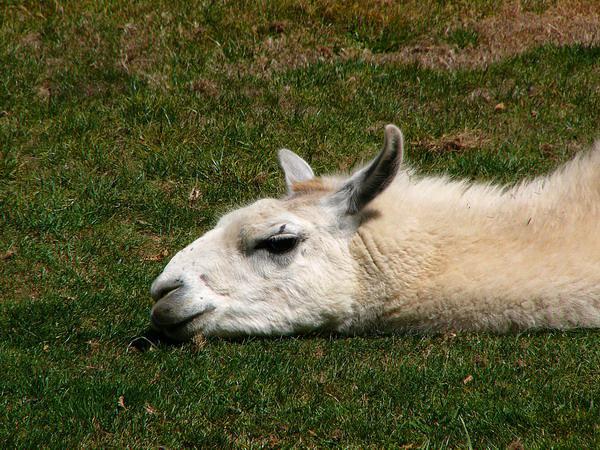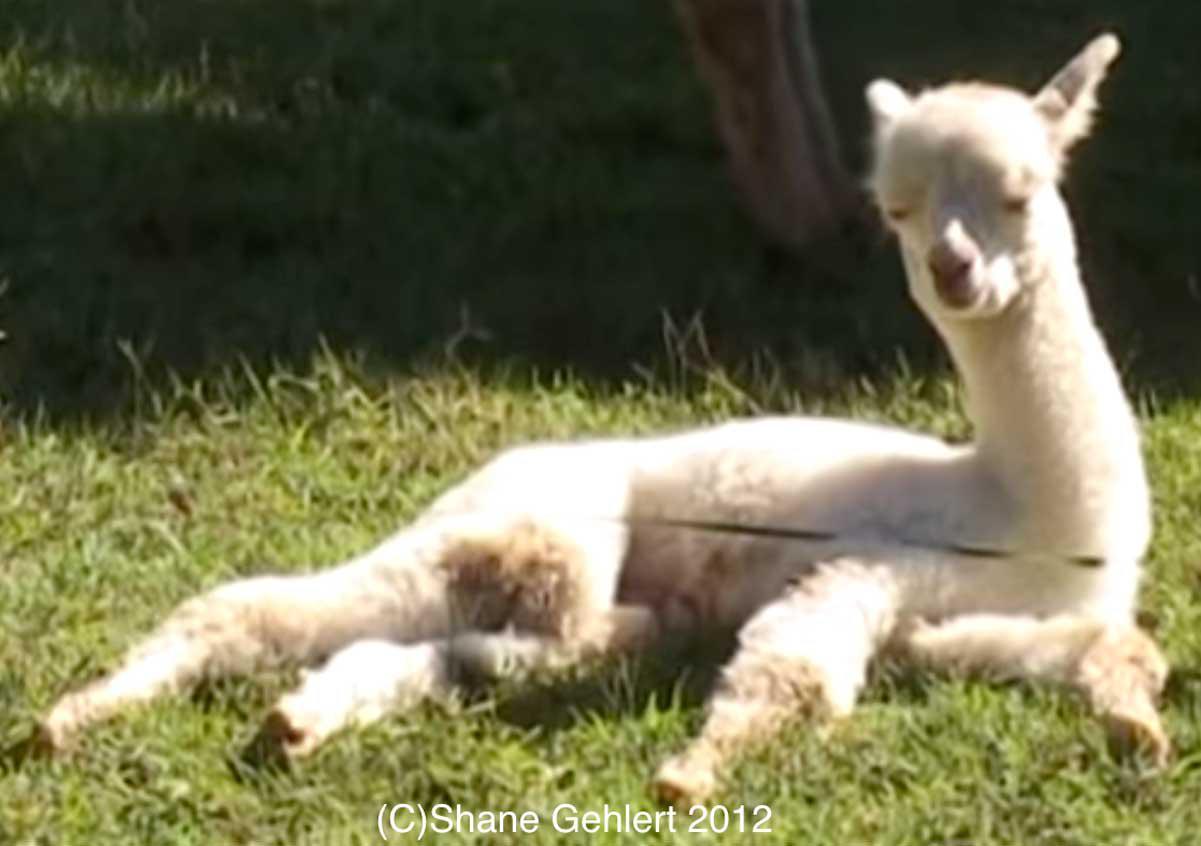The first image is the image on the left, the second image is the image on the right. For the images shown, is this caption "Each image contains one llama lying on the ground, and the left image features a brown-and-white llma with a pink harness and a rope at its tail end lying on its side on the grass." true? Answer yes or no. No. The first image is the image on the left, the second image is the image on the right. Analyze the images presented: Is the assertion "In one of the images, the llama has a leash on his neck." valid? Answer yes or no. No. 